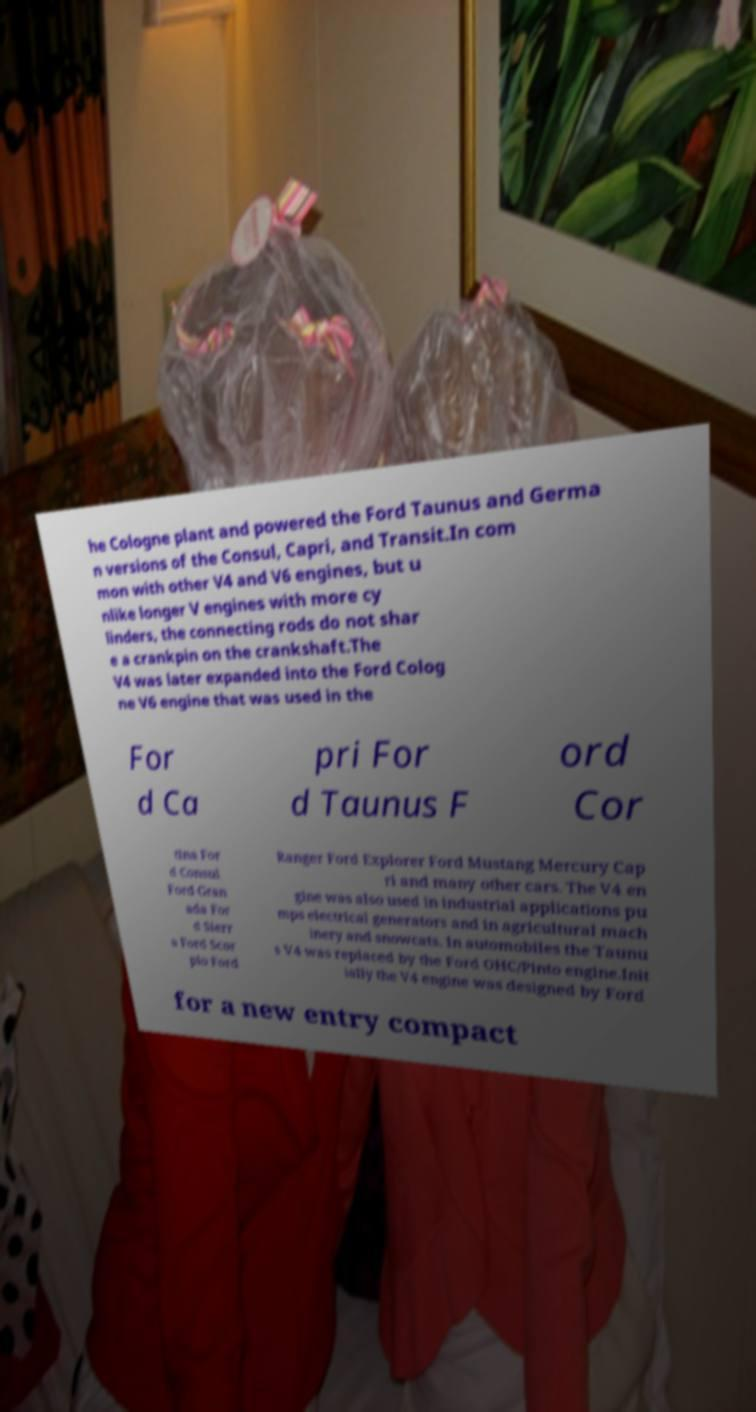Can you read and provide the text displayed in the image?This photo seems to have some interesting text. Can you extract and type it out for me? he Cologne plant and powered the Ford Taunus and Germa n versions of the Consul, Capri, and Transit.In com mon with other V4 and V6 engines, but u nlike longer V engines with more cy linders, the connecting rods do not shar e a crankpin on the crankshaft.The V4 was later expanded into the Ford Colog ne V6 engine that was used in the For d Ca pri For d Taunus F ord Cor tina For d Consul Ford Gran ada For d Sierr a Ford Scor pio Ford Ranger Ford Explorer Ford Mustang Mercury Cap ri and many other cars. The V4 en gine was also used in industrial applications pu mps electrical generators and in agricultural mach inery and snowcats. In automobiles the Taunu s V4 was replaced by the Ford OHC/Pinto engine.Init ially the V4 engine was designed by Ford for a new entry compact 